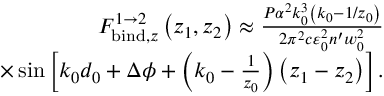Convert formula to latex. <formula><loc_0><loc_0><loc_500><loc_500>\begin{array} { r l r } & { F _ { b i n d , z } ^ { 1 \rightarrow 2 } \left ( z _ { 1 } , z _ { 2 } \right ) \approx \frac { P \alpha ^ { 2 } k _ { 0 } ^ { 3 } \left ( k _ { 0 } - 1 / z _ { 0 } \right ) } { 2 \pi ^ { 2 } c \varepsilon _ { 0 } ^ { 2 } n ^ { \prime } w _ { 0 } ^ { 2 } } } \\ & { \times \sin \left [ k _ { 0 } d _ { 0 } + \Delta \phi + \left ( k _ { 0 } - \frac { 1 } { z _ { 0 } } \right ) \left ( z _ { 1 } - z _ { 2 } \right ) \right ] . } \end{array}</formula> 